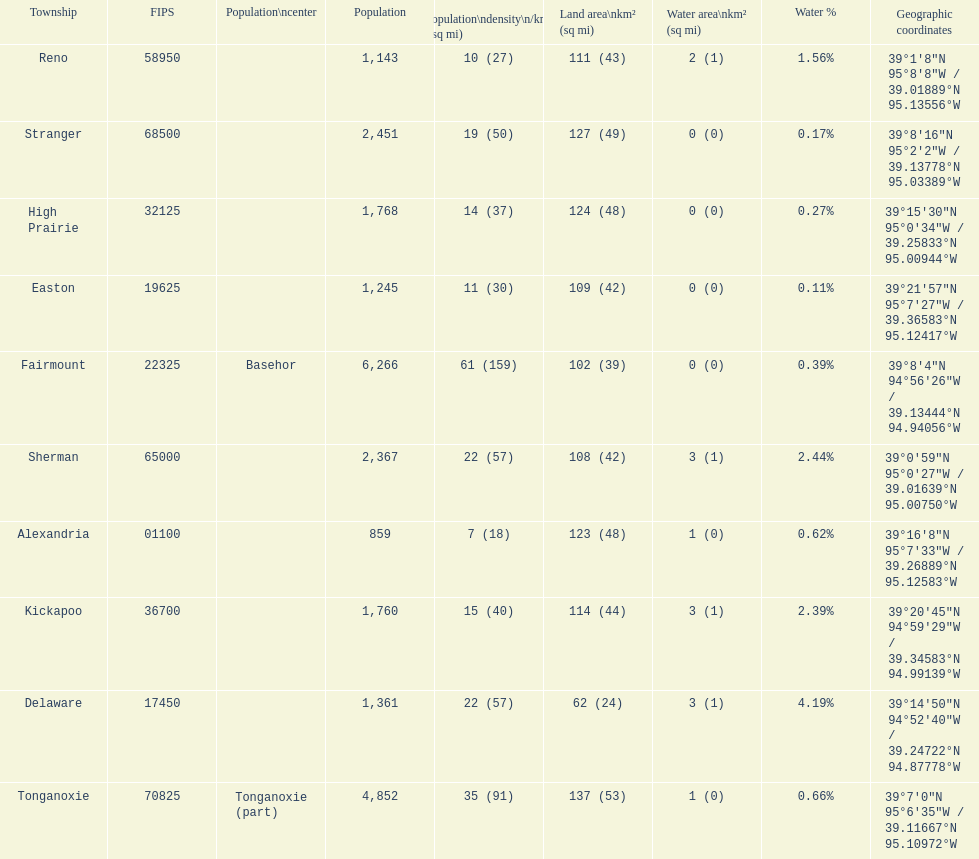What township has the most land area? Tonganoxie. Write the full table. {'header': ['Township', 'FIPS', 'Population\\ncenter', 'Population', 'Population\\ndensity\\n/km² (/sq\xa0mi)', 'Land area\\nkm² (sq\xa0mi)', 'Water area\\nkm² (sq\xa0mi)', 'Water\xa0%', 'Geographic coordinates'], 'rows': [['Reno', '58950', '', '1,143', '10 (27)', '111 (43)', '2 (1)', '1.56%', '39°1′8″N 95°8′8″W\ufeff / \ufeff39.01889°N 95.13556°W'], ['Stranger', '68500', '', '2,451', '19 (50)', '127 (49)', '0 (0)', '0.17%', '39°8′16″N 95°2′2″W\ufeff / \ufeff39.13778°N 95.03389°W'], ['High Prairie', '32125', '', '1,768', '14 (37)', '124 (48)', '0 (0)', '0.27%', '39°15′30″N 95°0′34″W\ufeff / \ufeff39.25833°N 95.00944°W'], ['Easton', '19625', '', '1,245', '11 (30)', '109 (42)', '0 (0)', '0.11%', '39°21′57″N 95°7′27″W\ufeff / \ufeff39.36583°N 95.12417°W'], ['Fairmount', '22325', 'Basehor', '6,266', '61 (159)', '102 (39)', '0 (0)', '0.39%', '39°8′4″N 94°56′26″W\ufeff / \ufeff39.13444°N 94.94056°W'], ['Sherman', '65000', '', '2,367', '22 (57)', '108 (42)', '3 (1)', '2.44%', '39°0′59″N 95°0′27″W\ufeff / \ufeff39.01639°N 95.00750°W'], ['Alexandria', '01100', '', '859', '7 (18)', '123 (48)', '1 (0)', '0.62%', '39°16′8″N 95°7′33″W\ufeff / \ufeff39.26889°N 95.12583°W'], ['Kickapoo', '36700', '', '1,760', '15 (40)', '114 (44)', '3 (1)', '2.39%', '39°20′45″N 94°59′29″W\ufeff / \ufeff39.34583°N 94.99139°W'], ['Delaware', '17450', '', '1,361', '22 (57)', '62 (24)', '3 (1)', '4.19%', '39°14′50″N 94°52′40″W\ufeff / \ufeff39.24722°N 94.87778°W'], ['Tonganoxie', '70825', 'Tonganoxie (part)', '4,852', '35 (91)', '137 (53)', '1 (0)', '0.66%', '39°7′0″N 95°6′35″W\ufeff / \ufeff39.11667°N 95.10972°W']]} 